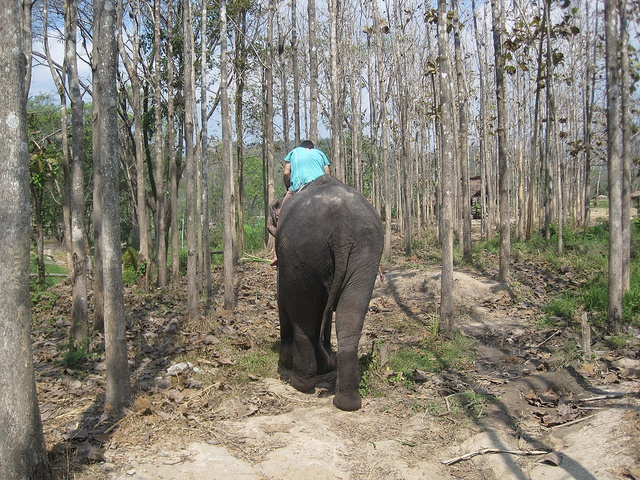Describe the objects in this image and their specific colors. I can see elephant in gray, black, and darkgray tones and people in gray, lightblue, and darkgray tones in this image. 